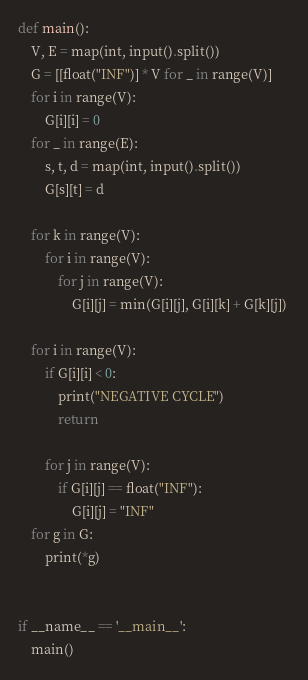<code> <loc_0><loc_0><loc_500><loc_500><_Python_>def main():
    V, E = map(int, input().split())
    G = [[float("INF")] * V for _ in range(V)]
    for i in range(V):
        G[i][i] = 0
    for _ in range(E):
        s, t, d = map(int, input().split())
        G[s][t] = d

    for k in range(V):
        for i in range(V):
            for j in range(V):
                G[i][j] = min(G[i][j], G[i][k] + G[k][j]) 

    for i in range(V):
        if G[i][i] < 0:
            print("NEGATIVE CYCLE")
            return

        for j in range(V):
            if G[i][j] == float("INF"):
                G[i][j] = "INF"
    for g in G:
        print(*g)


if __name__ == '__main__':
    main()

</code> 